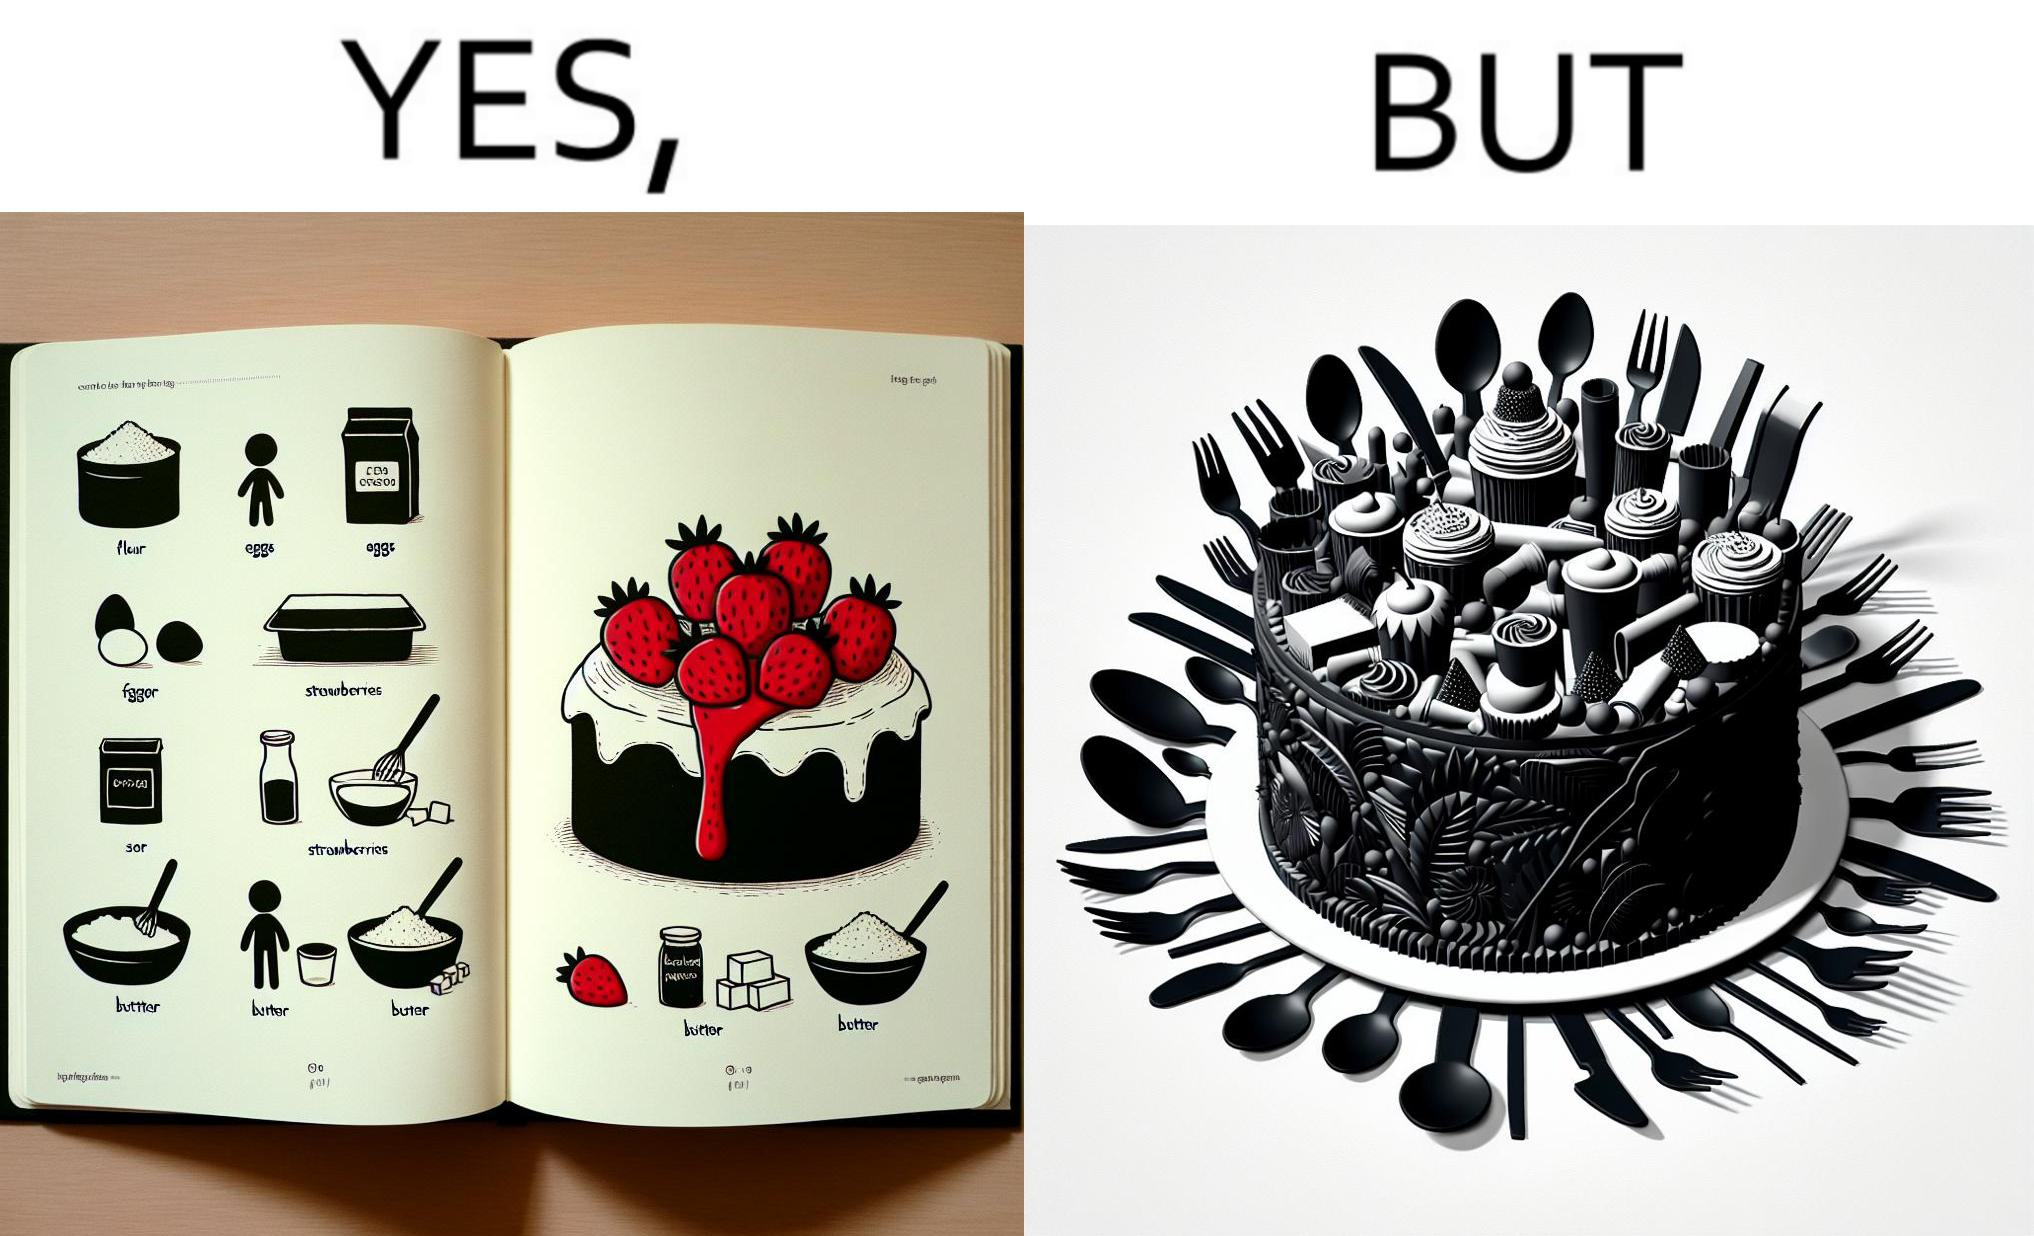What is the satirical meaning behind this image? The image is funny, as when making a strawberry cake using  a recipe book, the outcome is not quite what is expected, and one has to wash the used utensils afterwards as well. 